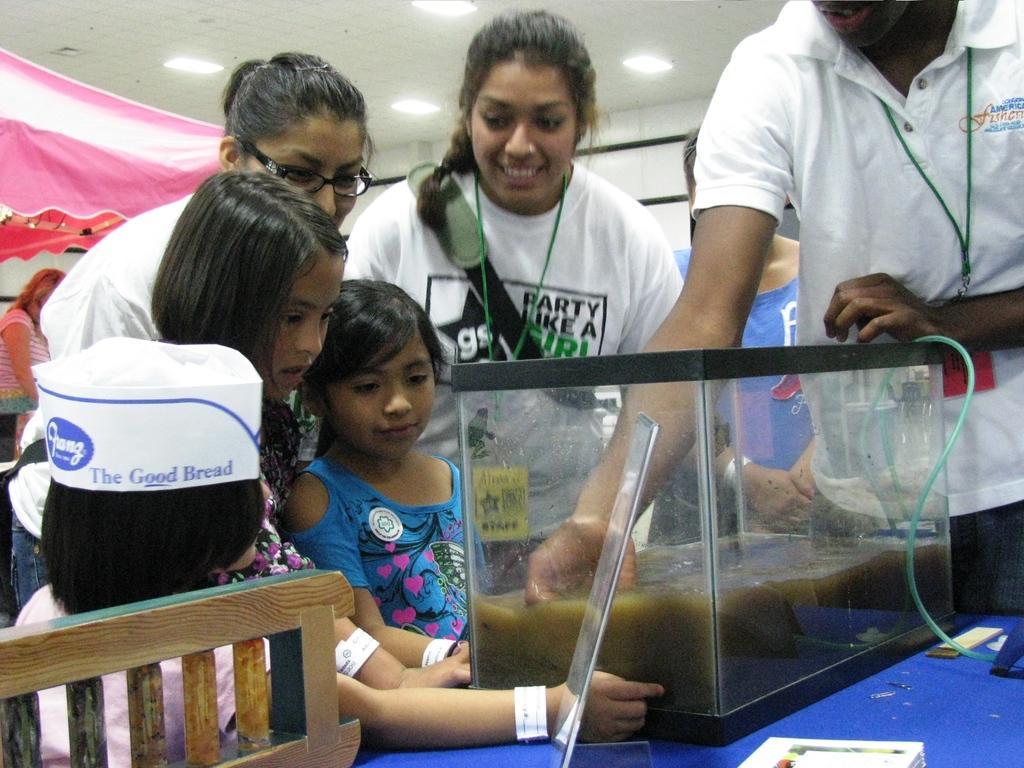Describe this image in one or two sentences. In this image we can see a group of people standing. In that a man is kept his hand in the water inside a glass container which is placed on the table. On the backside we can see a chair, a woman standing, a tent, a wall and a roof with some ceiling lights. 